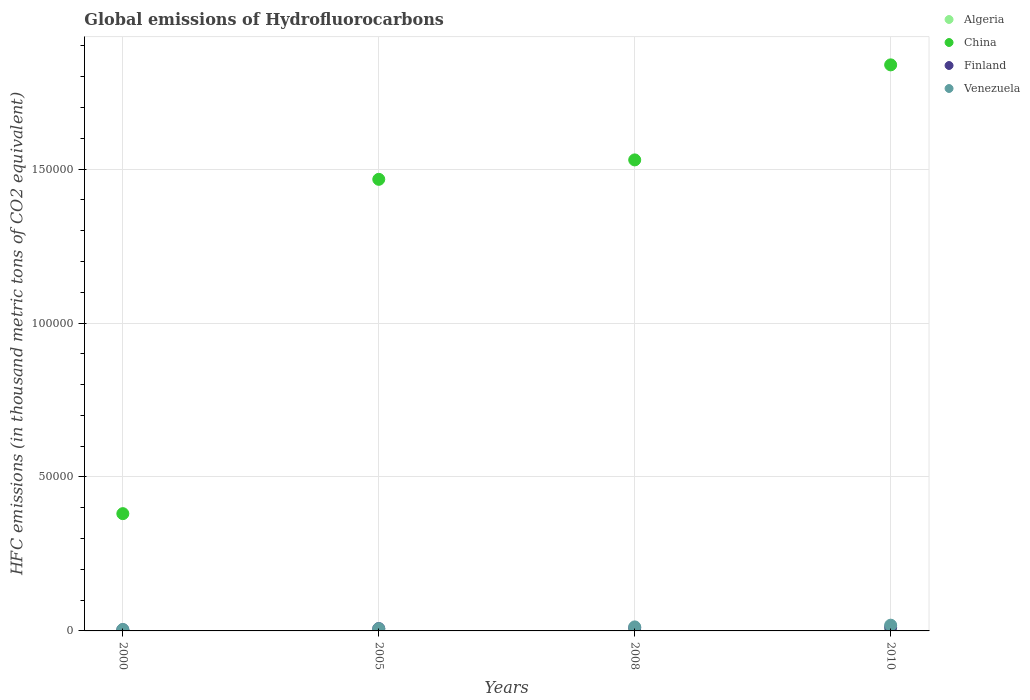How many different coloured dotlines are there?
Offer a terse response. 4. Is the number of dotlines equal to the number of legend labels?
Keep it short and to the point. Yes. What is the global emissions of Hydrofluorocarbons in Venezuela in 2000?
Your answer should be compact. 468.5. Across all years, what is the maximum global emissions of Hydrofluorocarbons in Algeria?
Keep it short and to the point. 275. Across all years, what is the minimum global emissions of Hydrofluorocarbons in Venezuela?
Provide a succinct answer. 468.5. What is the total global emissions of Hydrofluorocarbons in Venezuela in the graph?
Offer a terse response. 4377. What is the difference between the global emissions of Hydrofluorocarbons in Venezuela in 2005 and that in 2010?
Offer a very short reply. -1124.6. What is the difference between the global emissions of Hydrofluorocarbons in Venezuela in 2008 and the global emissions of Hydrofluorocarbons in China in 2010?
Your answer should be very brief. -1.83e+05. What is the average global emissions of Hydrofluorocarbons in Algeria per year?
Give a very brief answer. 183.12. In the year 2008, what is the difference between the global emissions of Hydrofluorocarbons in Venezuela and global emissions of Hydrofluorocarbons in Algeria?
Provide a short and direct response. 1076.9. In how many years, is the global emissions of Hydrofluorocarbons in Algeria greater than 60000 thousand metric tons?
Offer a very short reply. 0. What is the ratio of the global emissions of Hydrofluorocarbons in China in 2000 to that in 2005?
Your response must be concise. 0.26. Is the global emissions of Hydrofluorocarbons in Finland in 2000 less than that in 2005?
Make the answer very short. Yes. What is the difference between the highest and the second highest global emissions of Hydrofluorocarbons in Finland?
Provide a succinct answer. 199.8. What is the difference between the highest and the lowest global emissions of Hydrofluorocarbons in Finland?
Your response must be concise. 824.8. In how many years, is the global emissions of Hydrofluorocarbons in Venezuela greater than the average global emissions of Hydrofluorocarbons in Venezuela taken over all years?
Offer a very short reply. 2. Is the sum of the global emissions of Hydrofluorocarbons in China in 2000 and 2010 greater than the maximum global emissions of Hydrofluorocarbons in Finland across all years?
Offer a very short reply. Yes. Is it the case that in every year, the sum of the global emissions of Hydrofluorocarbons in Algeria and global emissions of Hydrofluorocarbons in China  is greater than the sum of global emissions of Hydrofluorocarbons in Finland and global emissions of Hydrofluorocarbons in Venezuela?
Your response must be concise. Yes. Does the global emissions of Hydrofluorocarbons in China monotonically increase over the years?
Your answer should be very brief. Yes. Is the global emissions of Hydrofluorocarbons in China strictly greater than the global emissions of Hydrofluorocarbons in Finland over the years?
Offer a very short reply. Yes. Is the global emissions of Hydrofluorocarbons in China strictly less than the global emissions of Hydrofluorocarbons in Venezuela over the years?
Make the answer very short. No. How many dotlines are there?
Your answer should be compact. 4. How many years are there in the graph?
Provide a short and direct response. 4. Are the values on the major ticks of Y-axis written in scientific E-notation?
Provide a short and direct response. No. Does the graph contain any zero values?
Your response must be concise. No. Does the graph contain grids?
Provide a short and direct response. Yes. What is the title of the graph?
Keep it short and to the point. Global emissions of Hydrofluorocarbons. Does "Slovak Republic" appear as one of the legend labels in the graph?
Make the answer very short. No. What is the label or title of the Y-axis?
Your answer should be very brief. HFC emissions (in thousand metric tons of CO2 equivalent). What is the HFC emissions (in thousand metric tons of CO2 equivalent) in Algeria in 2000?
Your answer should be very brief. 60.5. What is the HFC emissions (in thousand metric tons of CO2 equivalent) in China in 2000?
Your answer should be compact. 3.81e+04. What is the HFC emissions (in thousand metric tons of CO2 equivalent) in Finland in 2000?
Provide a succinct answer. 378.2. What is the HFC emissions (in thousand metric tons of CO2 equivalent) in Venezuela in 2000?
Ensure brevity in your answer.  468.5. What is the HFC emissions (in thousand metric tons of CO2 equivalent) in Algeria in 2005?
Your answer should be very brief. 166.8. What is the HFC emissions (in thousand metric tons of CO2 equivalent) in China in 2005?
Your answer should be very brief. 1.47e+05. What is the HFC emissions (in thousand metric tons of CO2 equivalent) of Finland in 2005?
Your response must be concise. 754.9. What is the HFC emissions (in thousand metric tons of CO2 equivalent) in Venezuela in 2005?
Keep it short and to the point. 738.4. What is the HFC emissions (in thousand metric tons of CO2 equivalent) of Algeria in 2008?
Your response must be concise. 230.2. What is the HFC emissions (in thousand metric tons of CO2 equivalent) in China in 2008?
Your answer should be compact. 1.53e+05. What is the HFC emissions (in thousand metric tons of CO2 equivalent) in Finland in 2008?
Your response must be concise. 1003.2. What is the HFC emissions (in thousand metric tons of CO2 equivalent) of Venezuela in 2008?
Provide a succinct answer. 1307.1. What is the HFC emissions (in thousand metric tons of CO2 equivalent) in Algeria in 2010?
Give a very brief answer. 275. What is the HFC emissions (in thousand metric tons of CO2 equivalent) in China in 2010?
Ensure brevity in your answer.  1.84e+05. What is the HFC emissions (in thousand metric tons of CO2 equivalent) of Finland in 2010?
Provide a succinct answer. 1203. What is the HFC emissions (in thousand metric tons of CO2 equivalent) of Venezuela in 2010?
Offer a terse response. 1863. Across all years, what is the maximum HFC emissions (in thousand metric tons of CO2 equivalent) of Algeria?
Ensure brevity in your answer.  275. Across all years, what is the maximum HFC emissions (in thousand metric tons of CO2 equivalent) of China?
Provide a succinct answer. 1.84e+05. Across all years, what is the maximum HFC emissions (in thousand metric tons of CO2 equivalent) of Finland?
Provide a short and direct response. 1203. Across all years, what is the maximum HFC emissions (in thousand metric tons of CO2 equivalent) in Venezuela?
Offer a terse response. 1863. Across all years, what is the minimum HFC emissions (in thousand metric tons of CO2 equivalent) of Algeria?
Provide a short and direct response. 60.5. Across all years, what is the minimum HFC emissions (in thousand metric tons of CO2 equivalent) of China?
Your response must be concise. 3.81e+04. Across all years, what is the minimum HFC emissions (in thousand metric tons of CO2 equivalent) of Finland?
Keep it short and to the point. 378.2. Across all years, what is the minimum HFC emissions (in thousand metric tons of CO2 equivalent) of Venezuela?
Give a very brief answer. 468.5. What is the total HFC emissions (in thousand metric tons of CO2 equivalent) in Algeria in the graph?
Offer a terse response. 732.5. What is the total HFC emissions (in thousand metric tons of CO2 equivalent) in China in the graph?
Make the answer very short. 5.22e+05. What is the total HFC emissions (in thousand metric tons of CO2 equivalent) of Finland in the graph?
Keep it short and to the point. 3339.3. What is the total HFC emissions (in thousand metric tons of CO2 equivalent) in Venezuela in the graph?
Provide a short and direct response. 4377. What is the difference between the HFC emissions (in thousand metric tons of CO2 equivalent) in Algeria in 2000 and that in 2005?
Offer a terse response. -106.3. What is the difference between the HFC emissions (in thousand metric tons of CO2 equivalent) in China in 2000 and that in 2005?
Your response must be concise. -1.09e+05. What is the difference between the HFC emissions (in thousand metric tons of CO2 equivalent) in Finland in 2000 and that in 2005?
Offer a terse response. -376.7. What is the difference between the HFC emissions (in thousand metric tons of CO2 equivalent) in Venezuela in 2000 and that in 2005?
Your answer should be very brief. -269.9. What is the difference between the HFC emissions (in thousand metric tons of CO2 equivalent) in Algeria in 2000 and that in 2008?
Provide a succinct answer. -169.7. What is the difference between the HFC emissions (in thousand metric tons of CO2 equivalent) in China in 2000 and that in 2008?
Offer a terse response. -1.15e+05. What is the difference between the HFC emissions (in thousand metric tons of CO2 equivalent) in Finland in 2000 and that in 2008?
Provide a short and direct response. -625. What is the difference between the HFC emissions (in thousand metric tons of CO2 equivalent) in Venezuela in 2000 and that in 2008?
Provide a succinct answer. -838.6. What is the difference between the HFC emissions (in thousand metric tons of CO2 equivalent) in Algeria in 2000 and that in 2010?
Provide a succinct answer. -214.5. What is the difference between the HFC emissions (in thousand metric tons of CO2 equivalent) in China in 2000 and that in 2010?
Offer a very short reply. -1.46e+05. What is the difference between the HFC emissions (in thousand metric tons of CO2 equivalent) of Finland in 2000 and that in 2010?
Provide a succinct answer. -824.8. What is the difference between the HFC emissions (in thousand metric tons of CO2 equivalent) in Venezuela in 2000 and that in 2010?
Keep it short and to the point. -1394.5. What is the difference between the HFC emissions (in thousand metric tons of CO2 equivalent) in Algeria in 2005 and that in 2008?
Your response must be concise. -63.4. What is the difference between the HFC emissions (in thousand metric tons of CO2 equivalent) in China in 2005 and that in 2008?
Provide a short and direct response. -6309. What is the difference between the HFC emissions (in thousand metric tons of CO2 equivalent) in Finland in 2005 and that in 2008?
Give a very brief answer. -248.3. What is the difference between the HFC emissions (in thousand metric tons of CO2 equivalent) of Venezuela in 2005 and that in 2008?
Make the answer very short. -568.7. What is the difference between the HFC emissions (in thousand metric tons of CO2 equivalent) of Algeria in 2005 and that in 2010?
Offer a very short reply. -108.2. What is the difference between the HFC emissions (in thousand metric tons of CO2 equivalent) of China in 2005 and that in 2010?
Give a very brief answer. -3.72e+04. What is the difference between the HFC emissions (in thousand metric tons of CO2 equivalent) in Finland in 2005 and that in 2010?
Keep it short and to the point. -448.1. What is the difference between the HFC emissions (in thousand metric tons of CO2 equivalent) in Venezuela in 2005 and that in 2010?
Your response must be concise. -1124.6. What is the difference between the HFC emissions (in thousand metric tons of CO2 equivalent) in Algeria in 2008 and that in 2010?
Offer a terse response. -44.8. What is the difference between the HFC emissions (in thousand metric tons of CO2 equivalent) in China in 2008 and that in 2010?
Provide a short and direct response. -3.09e+04. What is the difference between the HFC emissions (in thousand metric tons of CO2 equivalent) in Finland in 2008 and that in 2010?
Give a very brief answer. -199.8. What is the difference between the HFC emissions (in thousand metric tons of CO2 equivalent) of Venezuela in 2008 and that in 2010?
Keep it short and to the point. -555.9. What is the difference between the HFC emissions (in thousand metric tons of CO2 equivalent) in Algeria in 2000 and the HFC emissions (in thousand metric tons of CO2 equivalent) in China in 2005?
Offer a very short reply. -1.47e+05. What is the difference between the HFC emissions (in thousand metric tons of CO2 equivalent) of Algeria in 2000 and the HFC emissions (in thousand metric tons of CO2 equivalent) of Finland in 2005?
Your answer should be very brief. -694.4. What is the difference between the HFC emissions (in thousand metric tons of CO2 equivalent) of Algeria in 2000 and the HFC emissions (in thousand metric tons of CO2 equivalent) of Venezuela in 2005?
Give a very brief answer. -677.9. What is the difference between the HFC emissions (in thousand metric tons of CO2 equivalent) in China in 2000 and the HFC emissions (in thousand metric tons of CO2 equivalent) in Finland in 2005?
Offer a very short reply. 3.73e+04. What is the difference between the HFC emissions (in thousand metric tons of CO2 equivalent) in China in 2000 and the HFC emissions (in thousand metric tons of CO2 equivalent) in Venezuela in 2005?
Offer a very short reply. 3.74e+04. What is the difference between the HFC emissions (in thousand metric tons of CO2 equivalent) of Finland in 2000 and the HFC emissions (in thousand metric tons of CO2 equivalent) of Venezuela in 2005?
Keep it short and to the point. -360.2. What is the difference between the HFC emissions (in thousand metric tons of CO2 equivalent) of Algeria in 2000 and the HFC emissions (in thousand metric tons of CO2 equivalent) of China in 2008?
Your answer should be very brief. -1.53e+05. What is the difference between the HFC emissions (in thousand metric tons of CO2 equivalent) in Algeria in 2000 and the HFC emissions (in thousand metric tons of CO2 equivalent) in Finland in 2008?
Offer a very short reply. -942.7. What is the difference between the HFC emissions (in thousand metric tons of CO2 equivalent) of Algeria in 2000 and the HFC emissions (in thousand metric tons of CO2 equivalent) of Venezuela in 2008?
Give a very brief answer. -1246.6. What is the difference between the HFC emissions (in thousand metric tons of CO2 equivalent) in China in 2000 and the HFC emissions (in thousand metric tons of CO2 equivalent) in Finland in 2008?
Ensure brevity in your answer.  3.71e+04. What is the difference between the HFC emissions (in thousand metric tons of CO2 equivalent) in China in 2000 and the HFC emissions (in thousand metric tons of CO2 equivalent) in Venezuela in 2008?
Provide a succinct answer. 3.68e+04. What is the difference between the HFC emissions (in thousand metric tons of CO2 equivalent) in Finland in 2000 and the HFC emissions (in thousand metric tons of CO2 equivalent) in Venezuela in 2008?
Your answer should be compact. -928.9. What is the difference between the HFC emissions (in thousand metric tons of CO2 equivalent) in Algeria in 2000 and the HFC emissions (in thousand metric tons of CO2 equivalent) in China in 2010?
Your answer should be very brief. -1.84e+05. What is the difference between the HFC emissions (in thousand metric tons of CO2 equivalent) of Algeria in 2000 and the HFC emissions (in thousand metric tons of CO2 equivalent) of Finland in 2010?
Offer a terse response. -1142.5. What is the difference between the HFC emissions (in thousand metric tons of CO2 equivalent) in Algeria in 2000 and the HFC emissions (in thousand metric tons of CO2 equivalent) in Venezuela in 2010?
Your answer should be compact. -1802.5. What is the difference between the HFC emissions (in thousand metric tons of CO2 equivalent) of China in 2000 and the HFC emissions (in thousand metric tons of CO2 equivalent) of Finland in 2010?
Your response must be concise. 3.69e+04. What is the difference between the HFC emissions (in thousand metric tons of CO2 equivalent) of China in 2000 and the HFC emissions (in thousand metric tons of CO2 equivalent) of Venezuela in 2010?
Ensure brevity in your answer.  3.62e+04. What is the difference between the HFC emissions (in thousand metric tons of CO2 equivalent) in Finland in 2000 and the HFC emissions (in thousand metric tons of CO2 equivalent) in Venezuela in 2010?
Make the answer very short. -1484.8. What is the difference between the HFC emissions (in thousand metric tons of CO2 equivalent) of Algeria in 2005 and the HFC emissions (in thousand metric tons of CO2 equivalent) of China in 2008?
Your answer should be very brief. -1.53e+05. What is the difference between the HFC emissions (in thousand metric tons of CO2 equivalent) in Algeria in 2005 and the HFC emissions (in thousand metric tons of CO2 equivalent) in Finland in 2008?
Provide a succinct answer. -836.4. What is the difference between the HFC emissions (in thousand metric tons of CO2 equivalent) of Algeria in 2005 and the HFC emissions (in thousand metric tons of CO2 equivalent) of Venezuela in 2008?
Make the answer very short. -1140.3. What is the difference between the HFC emissions (in thousand metric tons of CO2 equivalent) in China in 2005 and the HFC emissions (in thousand metric tons of CO2 equivalent) in Finland in 2008?
Provide a short and direct response. 1.46e+05. What is the difference between the HFC emissions (in thousand metric tons of CO2 equivalent) of China in 2005 and the HFC emissions (in thousand metric tons of CO2 equivalent) of Venezuela in 2008?
Your answer should be very brief. 1.45e+05. What is the difference between the HFC emissions (in thousand metric tons of CO2 equivalent) in Finland in 2005 and the HFC emissions (in thousand metric tons of CO2 equivalent) in Venezuela in 2008?
Give a very brief answer. -552.2. What is the difference between the HFC emissions (in thousand metric tons of CO2 equivalent) of Algeria in 2005 and the HFC emissions (in thousand metric tons of CO2 equivalent) of China in 2010?
Your answer should be compact. -1.84e+05. What is the difference between the HFC emissions (in thousand metric tons of CO2 equivalent) in Algeria in 2005 and the HFC emissions (in thousand metric tons of CO2 equivalent) in Finland in 2010?
Provide a succinct answer. -1036.2. What is the difference between the HFC emissions (in thousand metric tons of CO2 equivalent) in Algeria in 2005 and the HFC emissions (in thousand metric tons of CO2 equivalent) in Venezuela in 2010?
Offer a terse response. -1696.2. What is the difference between the HFC emissions (in thousand metric tons of CO2 equivalent) in China in 2005 and the HFC emissions (in thousand metric tons of CO2 equivalent) in Finland in 2010?
Provide a short and direct response. 1.45e+05. What is the difference between the HFC emissions (in thousand metric tons of CO2 equivalent) in China in 2005 and the HFC emissions (in thousand metric tons of CO2 equivalent) in Venezuela in 2010?
Your answer should be compact. 1.45e+05. What is the difference between the HFC emissions (in thousand metric tons of CO2 equivalent) in Finland in 2005 and the HFC emissions (in thousand metric tons of CO2 equivalent) in Venezuela in 2010?
Give a very brief answer. -1108.1. What is the difference between the HFC emissions (in thousand metric tons of CO2 equivalent) of Algeria in 2008 and the HFC emissions (in thousand metric tons of CO2 equivalent) of China in 2010?
Ensure brevity in your answer.  -1.84e+05. What is the difference between the HFC emissions (in thousand metric tons of CO2 equivalent) in Algeria in 2008 and the HFC emissions (in thousand metric tons of CO2 equivalent) in Finland in 2010?
Offer a very short reply. -972.8. What is the difference between the HFC emissions (in thousand metric tons of CO2 equivalent) of Algeria in 2008 and the HFC emissions (in thousand metric tons of CO2 equivalent) of Venezuela in 2010?
Your answer should be compact. -1632.8. What is the difference between the HFC emissions (in thousand metric tons of CO2 equivalent) of China in 2008 and the HFC emissions (in thousand metric tons of CO2 equivalent) of Finland in 2010?
Keep it short and to the point. 1.52e+05. What is the difference between the HFC emissions (in thousand metric tons of CO2 equivalent) of China in 2008 and the HFC emissions (in thousand metric tons of CO2 equivalent) of Venezuela in 2010?
Ensure brevity in your answer.  1.51e+05. What is the difference between the HFC emissions (in thousand metric tons of CO2 equivalent) of Finland in 2008 and the HFC emissions (in thousand metric tons of CO2 equivalent) of Venezuela in 2010?
Offer a terse response. -859.8. What is the average HFC emissions (in thousand metric tons of CO2 equivalent) in Algeria per year?
Offer a terse response. 183.12. What is the average HFC emissions (in thousand metric tons of CO2 equivalent) of China per year?
Your answer should be compact. 1.30e+05. What is the average HFC emissions (in thousand metric tons of CO2 equivalent) in Finland per year?
Offer a very short reply. 834.83. What is the average HFC emissions (in thousand metric tons of CO2 equivalent) in Venezuela per year?
Provide a short and direct response. 1094.25. In the year 2000, what is the difference between the HFC emissions (in thousand metric tons of CO2 equivalent) in Algeria and HFC emissions (in thousand metric tons of CO2 equivalent) in China?
Your answer should be very brief. -3.80e+04. In the year 2000, what is the difference between the HFC emissions (in thousand metric tons of CO2 equivalent) of Algeria and HFC emissions (in thousand metric tons of CO2 equivalent) of Finland?
Your response must be concise. -317.7. In the year 2000, what is the difference between the HFC emissions (in thousand metric tons of CO2 equivalent) of Algeria and HFC emissions (in thousand metric tons of CO2 equivalent) of Venezuela?
Offer a very short reply. -408. In the year 2000, what is the difference between the HFC emissions (in thousand metric tons of CO2 equivalent) of China and HFC emissions (in thousand metric tons of CO2 equivalent) of Finland?
Keep it short and to the point. 3.77e+04. In the year 2000, what is the difference between the HFC emissions (in thousand metric tons of CO2 equivalent) of China and HFC emissions (in thousand metric tons of CO2 equivalent) of Venezuela?
Your response must be concise. 3.76e+04. In the year 2000, what is the difference between the HFC emissions (in thousand metric tons of CO2 equivalent) in Finland and HFC emissions (in thousand metric tons of CO2 equivalent) in Venezuela?
Keep it short and to the point. -90.3. In the year 2005, what is the difference between the HFC emissions (in thousand metric tons of CO2 equivalent) in Algeria and HFC emissions (in thousand metric tons of CO2 equivalent) in China?
Make the answer very short. -1.47e+05. In the year 2005, what is the difference between the HFC emissions (in thousand metric tons of CO2 equivalent) in Algeria and HFC emissions (in thousand metric tons of CO2 equivalent) in Finland?
Keep it short and to the point. -588.1. In the year 2005, what is the difference between the HFC emissions (in thousand metric tons of CO2 equivalent) in Algeria and HFC emissions (in thousand metric tons of CO2 equivalent) in Venezuela?
Your answer should be very brief. -571.6. In the year 2005, what is the difference between the HFC emissions (in thousand metric tons of CO2 equivalent) of China and HFC emissions (in thousand metric tons of CO2 equivalent) of Finland?
Provide a succinct answer. 1.46e+05. In the year 2005, what is the difference between the HFC emissions (in thousand metric tons of CO2 equivalent) in China and HFC emissions (in thousand metric tons of CO2 equivalent) in Venezuela?
Offer a terse response. 1.46e+05. In the year 2005, what is the difference between the HFC emissions (in thousand metric tons of CO2 equivalent) of Finland and HFC emissions (in thousand metric tons of CO2 equivalent) of Venezuela?
Ensure brevity in your answer.  16.5. In the year 2008, what is the difference between the HFC emissions (in thousand metric tons of CO2 equivalent) in Algeria and HFC emissions (in thousand metric tons of CO2 equivalent) in China?
Offer a very short reply. -1.53e+05. In the year 2008, what is the difference between the HFC emissions (in thousand metric tons of CO2 equivalent) of Algeria and HFC emissions (in thousand metric tons of CO2 equivalent) of Finland?
Offer a very short reply. -773. In the year 2008, what is the difference between the HFC emissions (in thousand metric tons of CO2 equivalent) of Algeria and HFC emissions (in thousand metric tons of CO2 equivalent) of Venezuela?
Offer a terse response. -1076.9. In the year 2008, what is the difference between the HFC emissions (in thousand metric tons of CO2 equivalent) in China and HFC emissions (in thousand metric tons of CO2 equivalent) in Finland?
Your answer should be compact. 1.52e+05. In the year 2008, what is the difference between the HFC emissions (in thousand metric tons of CO2 equivalent) of China and HFC emissions (in thousand metric tons of CO2 equivalent) of Venezuela?
Your response must be concise. 1.52e+05. In the year 2008, what is the difference between the HFC emissions (in thousand metric tons of CO2 equivalent) of Finland and HFC emissions (in thousand metric tons of CO2 equivalent) of Venezuela?
Your answer should be very brief. -303.9. In the year 2010, what is the difference between the HFC emissions (in thousand metric tons of CO2 equivalent) in Algeria and HFC emissions (in thousand metric tons of CO2 equivalent) in China?
Provide a short and direct response. -1.84e+05. In the year 2010, what is the difference between the HFC emissions (in thousand metric tons of CO2 equivalent) in Algeria and HFC emissions (in thousand metric tons of CO2 equivalent) in Finland?
Keep it short and to the point. -928. In the year 2010, what is the difference between the HFC emissions (in thousand metric tons of CO2 equivalent) in Algeria and HFC emissions (in thousand metric tons of CO2 equivalent) in Venezuela?
Make the answer very short. -1588. In the year 2010, what is the difference between the HFC emissions (in thousand metric tons of CO2 equivalent) in China and HFC emissions (in thousand metric tons of CO2 equivalent) in Finland?
Ensure brevity in your answer.  1.83e+05. In the year 2010, what is the difference between the HFC emissions (in thousand metric tons of CO2 equivalent) in China and HFC emissions (in thousand metric tons of CO2 equivalent) in Venezuela?
Offer a terse response. 1.82e+05. In the year 2010, what is the difference between the HFC emissions (in thousand metric tons of CO2 equivalent) in Finland and HFC emissions (in thousand metric tons of CO2 equivalent) in Venezuela?
Provide a short and direct response. -660. What is the ratio of the HFC emissions (in thousand metric tons of CO2 equivalent) of Algeria in 2000 to that in 2005?
Provide a short and direct response. 0.36. What is the ratio of the HFC emissions (in thousand metric tons of CO2 equivalent) of China in 2000 to that in 2005?
Your answer should be very brief. 0.26. What is the ratio of the HFC emissions (in thousand metric tons of CO2 equivalent) of Finland in 2000 to that in 2005?
Offer a terse response. 0.5. What is the ratio of the HFC emissions (in thousand metric tons of CO2 equivalent) of Venezuela in 2000 to that in 2005?
Your answer should be very brief. 0.63. What is the ratio of the HFC emissions (in thousand metric tons of CO2 equivalent) of Algeria in 2000 to that in 2008?
Offer a very short reply. 0.26. What is the ratio of the HFC emissions (in thousand metric tons of CO2 equivalent) in China in 2000 to that in 2008?
Make the answer very short. 0.25. What is the ratio of the HFC emissions (in thousand metric tons of CO2 equivalent) in Finland in 2000 to that in 2008?
Your response must be concise. 0.38. What is the ratio of the HFC emissions (in thousand metric tons of CO2 equivalent) in Venezuela in 2000 to that in 2008?
Offer a very short reply. 0.36. What is the ratio of the HFC emissions (in thousand metric tons of CO2 equivalent) in Algeria in 2000 to that in 2010?
Offer a very short reply. 0.22. What is the ratio of the HFC emissions (in thousand metric tons of CO2 equivalent) of China in 2000 to that in 2010?
Give a very brief answer. 0.21. What is the ratio of the HFC emissions (in thousand metric tons of CO2 equivalent) of Finland in 2000 to that in 2010?
Your answer should be very brief. 0.31. What is the ratio of the HFC emissions (in thousand metric tons of CO2 equivalent) in Venezuela in 2000 to that in 2010?
Provide a succinct answer. 0.25. What is the ratio of the HFC emissions (in thousand metric tons of CO2 equivalent) in Algeria in 2005 to that in 2008?
Offer a very short reply. 0.72. What is the ratio of the HFC emissions (in thousand metric tons of CO2 equivalent) of China in 2005 to that in 2008?
Give a very brief answer. 0.96. What is the ratio of the HFC emissions (in thousand metric tons of CO2 equivalent) of Finland in 2005 to that in 2008?
Ensure brevity in your answer.  0.75. What is the ratio of the HFC emissions (in thousand metric tons of CO2 equivalent) in Venezuela in 2005 to that in 2008?
Provide a short and direct response. 0.56. What is the ratio of the HFC emissions (in thousand metric tons of CO2 equivalent) in Algeria in 2005 to that in 2010?
Make the answer very short. 0.61. What is the ratio of the HFC emissions (in thousand metric tons of CO2 equivalent) of China in 2005 to that in 2010?
Make the answer very short. 0.8. What is the ratio of the HFC emissions (in thousand metric tons of CO2 equivalent) in Finland in 2005 to that in 2010?
Give a very brief answer. 0.63. What is the ratio of the HFC emissions (in thousand metric tons of CO2 equivalent) in Venezuela in 2005 to that in 2010?
Provide a short and direct response. 0.4. What is the ratio of the HFC emissions (in thousand metric tons of CO2 equivalent) in Algeria in 2008 to that in 2010?
Give a very brief answer. 0.84. What is the ratio of the HFC emissions (in thousand metric tons of CO2 equivalent) in China in 2008 to that in 2010?
Offer a terse response. 0.83. What is the ratio of the HFC emissions (in thousand metric tons of CO2 equivalent) of Finland in 2008 to that in 2010?
Ensure brevity in your answer.  0.83. What is the ratio of the HFC emissions (in thousand metric tons of CO2 equivalent) of Venezuela in 2008 to that in 2010?
Make the answer very short. 0.7. What is the difference between the highest and the second highest HFC emissions (in thousand metric tons of CO2 equivalent) of Algeria?
Provide a succinct answer. 44.8. What is the difference between the highest and the second highest HFC emissions (in thousand metric tons of CO2 equivalent) in China?
Make the answer very short. 3.09e+04. What is the difference between the highest and the second highest HFC emissions (in thousand metric tons of CO2 equivalent) in Finland?
Ensure brevity in your answer.  199.8. What is the difference between the highest and the second highest HFC emissions (in thousand metric tons of CO2 equivalent) in Venezuela?
Keep it short and to the point. 555.9. What is the difference between the highest and the lowest HFC emissions (in thousand metric tons of CO2 equivalent) of Algeria?
Offer a very short reply. 214.5. What is the difference between the highest and the lowest HFC emissions (in thousand metric tons of CO2 equivalent) in China?
Your answer should be very brief. 1.46e+05. What is the difference between the highest and the lowest HFC emissions (in thousand metric tons of CO2 equivalent) in Finland?
Ensure brevity in your answer.  824.8. What is the difference between the highest and the lowest HFC emissions (in thousand metric tons of CO2 equivalent) in Venezuela?
Offer a terse response. 1394.5. 